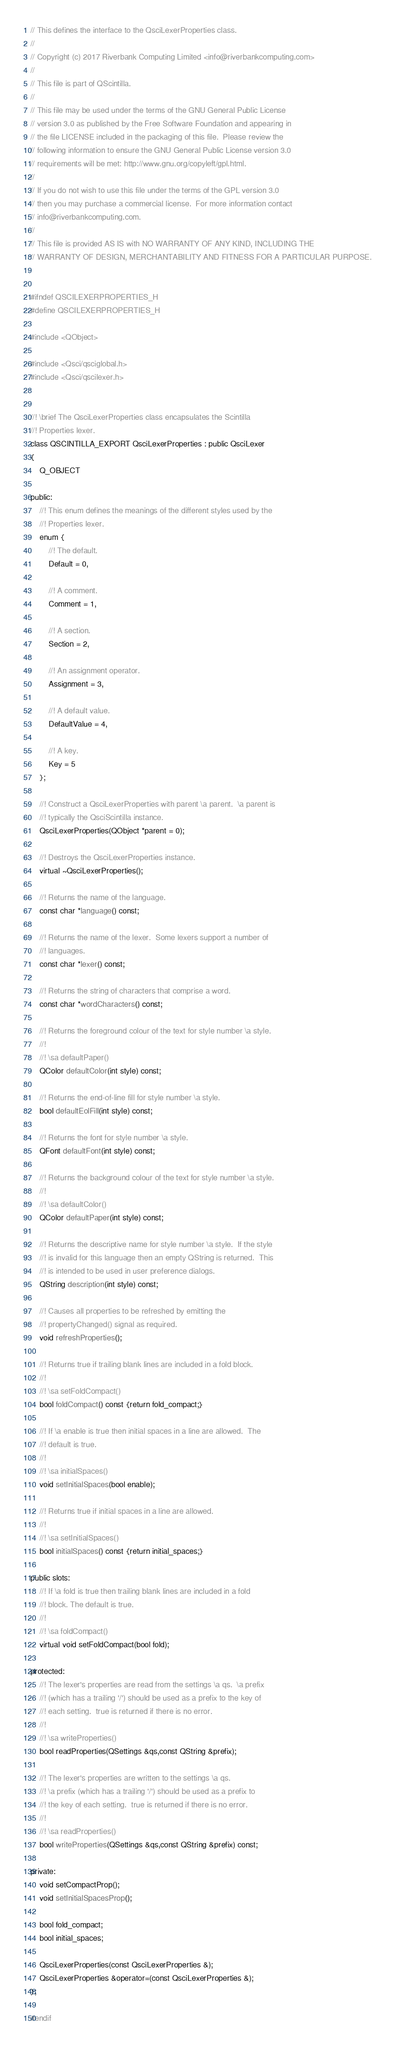Convert code to text. <code><loc_0><loc_0><loc_500><loc_500><_C_>// This defines the interface to the QsciLexerProperties class.
//
// Copyright (c) 2017 Riverbank Computing Limited <info@riverbankcomputing.com>
// 
// This file is part of QScintilla.
// 
// This file may be used under the terms of the GNU General Public License
// version 3.0 as published by the Free Software Foundation and appearing in
// the file LICENSE included in the packaging of this file.  Please review the
// following information to ensure the GNU General Public License version 3.0
// requirements will be met: http://www.gnu.org/copyleft/gpl.html.
// 
// If you do not wish to use this file under the terms of the GPL version 3.0
// then you may purchase a commercial license.  For more information contact
// info@riverbankcomputing.com.
// 
// This file is provided AS IS with NO WARRANTY OF ANY KIND, INCLUDING THE
// WARRANTY OF DESIGN, MERCHANTABILITY AND FITNESS FOR A PARTICULAR PURPOSE.


#ifndef QSCILEXERPROPERTIES_H
#define QSCILEXERPROPERTIES_H

#include <QObject>

#include <Qsci/qsciglobal.h>
#include <Qsci/qscilexer.h>


//! \brief The QsciLexerProperties class encapsulates the Scintilla
//! Properties lexer.
class QSCINTILLA_EXPORT QsciLexerProperties : public QsciLexer
{
    Q_OBJECT

public:
    //! This enum defines the meanings of the different styles used by the
    //! Properties lexer.
    enum {
        //! The default.
        Default = 0,

        //! A comment.
        Comment = 1,

        //! A section.
        Section = 2,

        //! An assignment operator.
        Assignment = 3,

        //! A default value.
        DefaultValue = 4,

        //! A key.
        Key = 5
    };

    //! Construct a QsciLexerProperties with parent \a parent.  \a parent is
    //! typically the QsciScintilla instance.
    QsciLexerProperties(QObject *parent = 0);

    //! Destroys the QsciLexerProperties instance.
    virtual ~QsciLexerProperties();

    //! Returns the name of the language.
    const char *language() const;

    //! Returns the name of the lexer.  Some lexers support a number of
    //! languages.
    const char *lexer() const;

    //! Returns the string of characters that comprise a word.
    const char *wordCharacters() const;

    //! Returns the foreground colour of the text for style number \a style.
    //!
    //! \sa defaultPaper()
    QColor defaultColor(int style) const;

    //! Returns the end-of-line fill for style number \a style.
    bool defaultEolFill(int style) const;

    //! Returns the font for style number \a style.
    QFont defaultFont(int style) const;

    //! Returns the background colour of the text for style number \a style.
    //!
    //! \sa defaultColor()
    QColor defaultPaper(int style) const;

    //! Returns the descriptive name for style number \a style.  If the style
    //! is invalid for this language then an empty QString is returned.  This
    //! is intended to be used in user preference dialogs.
    QString description(int style) const;

    //! Causes all properties to be refreshed by emitting the
    //! propertyChanged() signal as required.
    void refreshProperties();

    //! Returns true if trailing blank lines are included in a fold block.
    //!
    //! \sa setFoldCompact()
    bool foldCompact() const {return fold_compact;}

    //! If \a enable is true then initial spaces in a line are allowed.  The
    //! default is true.
    //!
    //! \sa initialSpaces()
    void setInitialSpaces(bool enable);

    //! Returns true if initial spaces in a line are allowed.
    //!
    //! \sa setInitialSpaces()
    bool initialSpaces() const {return initial_spaces;}

public slots:
    //! If \a fold is true then trailing blank lines are included in a fold
    //! block. The default is true.
    //!
    //! \sa foldCompact()
    virtual void setFoldCompact(bool fold);

protected:
    //! The lexer's properties are read from the settings \a qs.  \a prefix
    //! (which has a trailing '/') should be used as a prefix to the key of
    //! each setting.  true is returned if there is no error.
    //!
    //! \sa writeProperties()
    bool readProperties(QSettings &qs,const QString &prefix);

    //! The lexer's properties are written to the settings \a qs.
    //! \a prefix (which has a trailing '/') should be used as a prefix to
    //! the key of each setting.  true is returned if there is no error.
    //!
    //! \sa readProperties()
    bool writeProperties(QSettings &qs,const QString &prefix) const;

private:
    void setCompactProp();
    void setInitialSpacesProp();

    bool fold_compact;
    bool initial_spaces;

    QsciLexerProperties(const QsciLexerProperties &);
    QsciLexerProperties &operator=(const QsciLexerProperties &);
};

#endif
</code> 